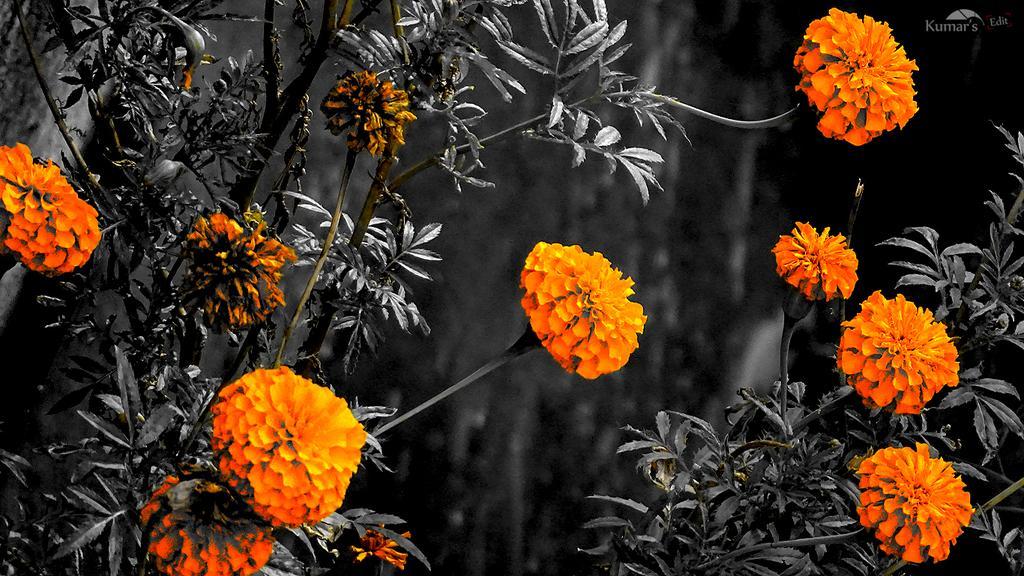Could you give a brief overview of what you see in this image? This image consists of flowers in orange color along with the leaves. And there are plants. The background is blurred. 